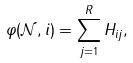Convert formula to latex. <formula><loc_0><loc_0><loc_500><loc_500>\varphi ( \mathcal { N } , i ) = \sum _ { j = 1 } ^ { R } H _ { i j } ,</formula> 